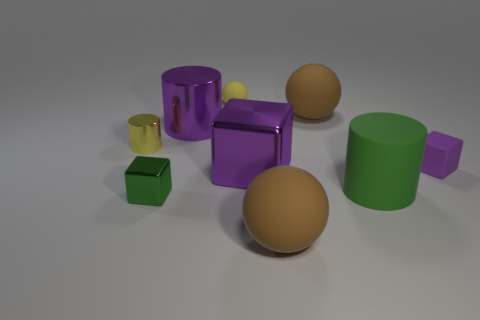Subtract all large metal cylinders. How many cylinders are left? 2 Subtract all brown spheres. How many spheres are left? 1 Subtract all gray blocks. How many brown balls are left? 2 Subtract all blocks. How many objects are left? 6 Add 8 small green cubes. How many small green cubes exist? 9 Subtract 0 red cylinders. How many objects are left? 9 Subtract all cyan cylinders. Subtract all purple cubes. How many cylinders are left? 3 Subtract all large purple metallic spheres. Subtract all big balls. How many objects are left? 7 Add 9 green cubes. How many green cubes are left? 10 